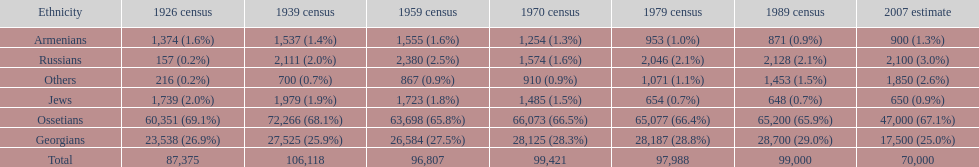How many russians lived in south ossetia in 1970? 1,574. 